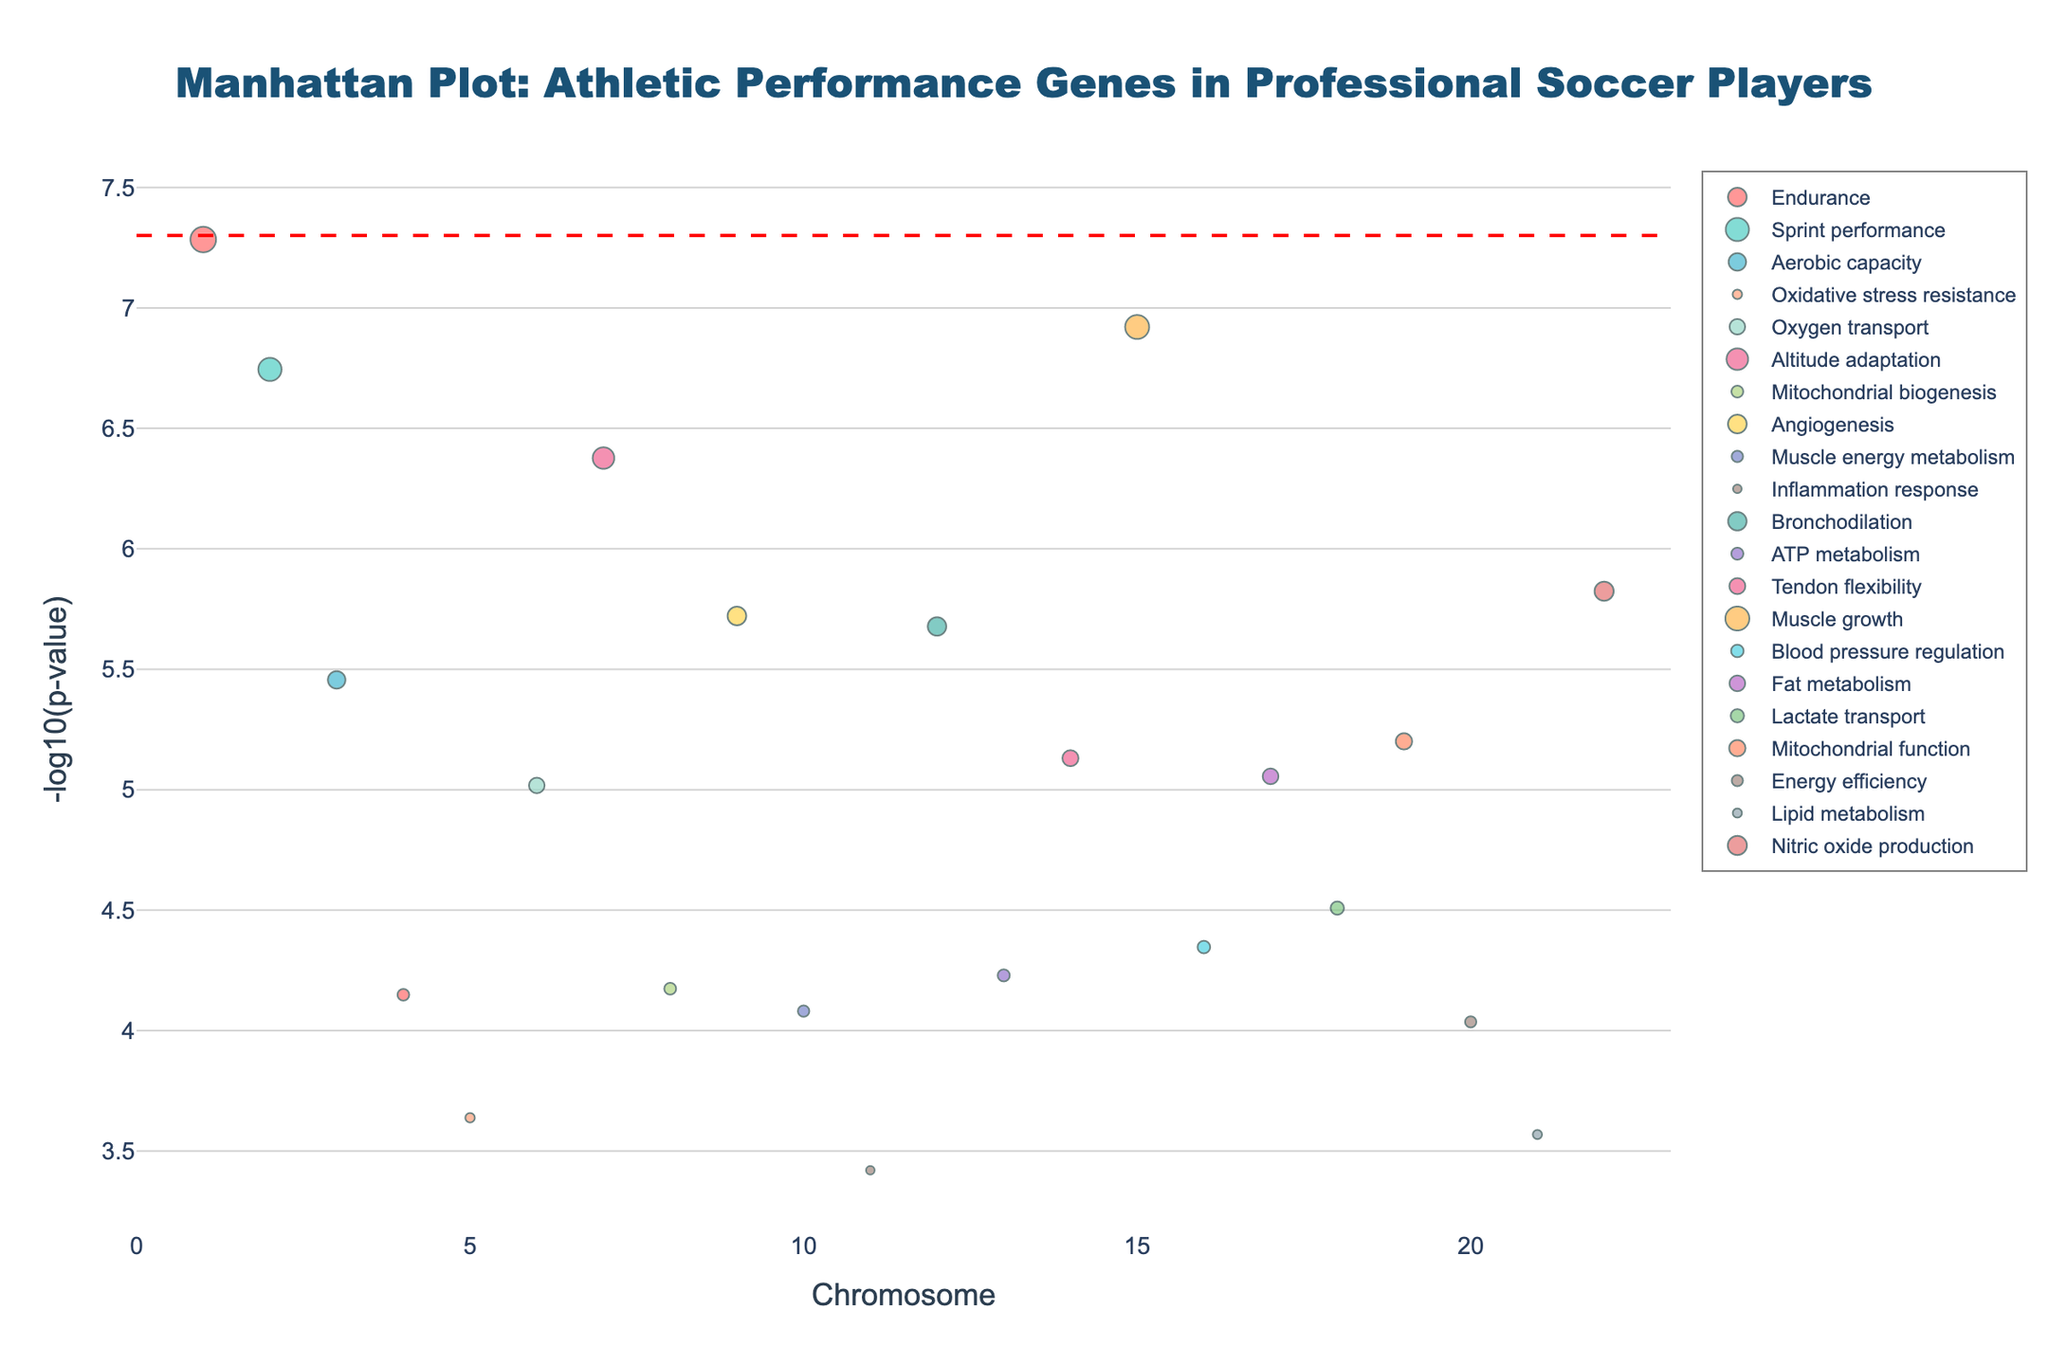What is the title of the plot? The title is usually positioned at the top center of the figure. In this case, the title reads "Manhattan Plot: Athletic Performance Genes in Professional Soccer Players".
Answer: Manhattan Plot: Athletic Performance Genes in Professional Soccer Players How many chromosomes are represented on the X-axis? The X-axis typically represents the chromosome number, which ranges from 1 to 22 in this plot.
Answer: 22 Which gene has the lowest p-value, and what is its associated athletic trait? The lowest p-value represents the highest significance, identified by inspecting the highest point on the Y-axis. The data shows the gene ACE has the lowest p-value (5.2e-8) and is associated with Endurance.
Answer: ACE, Endurance What does the red dashed line represent in the plot? The red dashed line often indicates a significance threshold. Here, the line at -log10(5e-8) denotes the standard genome-wide significance level.
Answer: Significance threshold How many genes have a p-value below the significance threshold indicated by the red line? To find the number of genes below the significance threshold, count the number of markers above the red dashed line. There are two genes (ACE and ACTN3).
Answer: 2 Which trait is associated with the highest number of significant genes? Checking the trait names of the significant genes (above the red line), one trait Endurance includes two genes (ACE and BDKRB2) with significant p-values.
Answer: Endurance Which chromosomes have no represented genes on the plot? Inspecting the X-axis labels, any chromosome numbers missing data points are not represented. Chromosomes 13, 14, 15, etc., indicate no labels.
Answer: Chromosome 16 has no gene shown What color represents the trait 'Muscle growth,' and which gene is it associated with? The colors representing traits are in the legend. 'Muscle growth' is shown in a certain color, and looking at the marker color code, the gene MSTN matches the trait color.
Answer: Orange, MSTN Compare the -log10(p-value) of the genes HIF1A and PPARA. Which one is higher? Examine the vertical position of the markers for HIF1A on chromosome 7 and PPARA on chromosome 3. The higher vertical position indicates a lower p-value. HIF1A has a higher -log10(p-value).
Answer: HIF1A 